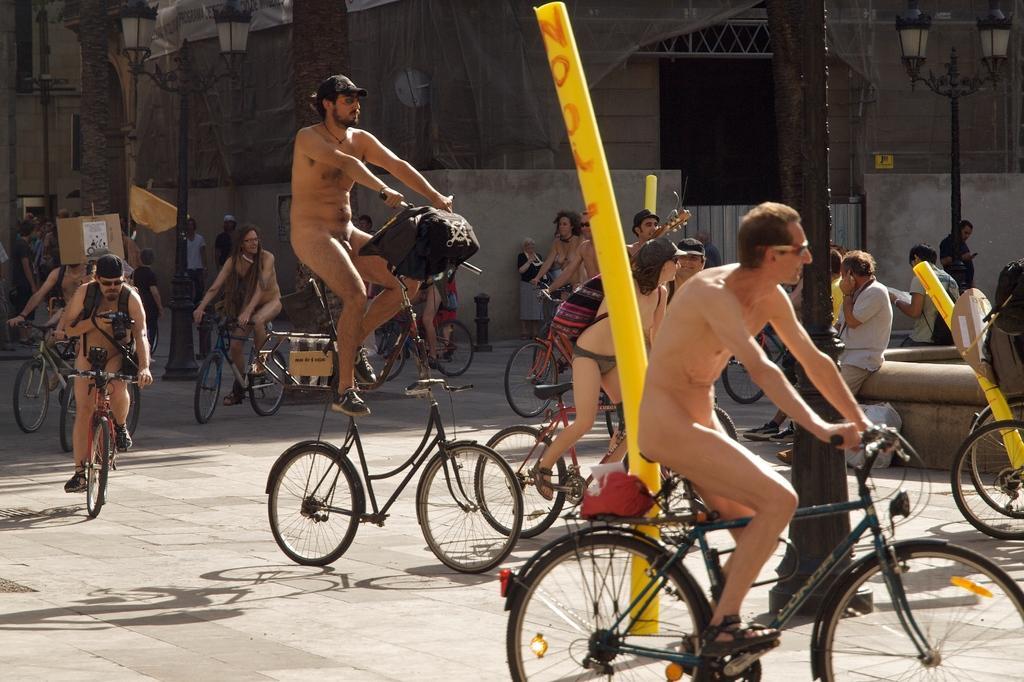Please provide a concise description of this image. In this image we can see people riding their bicycles on the road. In the background we can see street lights and building. 